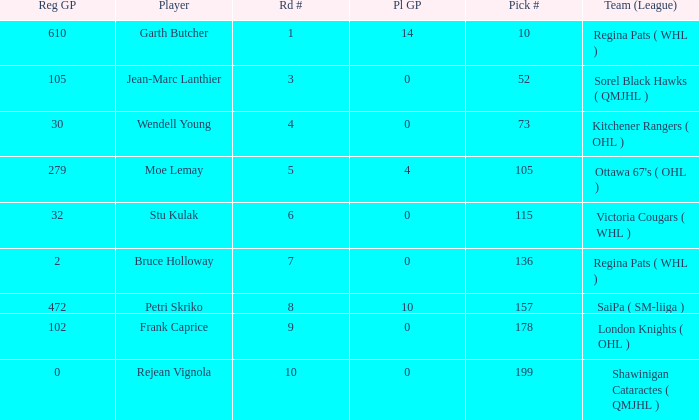What is the sum number of Pl GP when the pick number is 178 and the road number is bigger than 9? 0.0. 